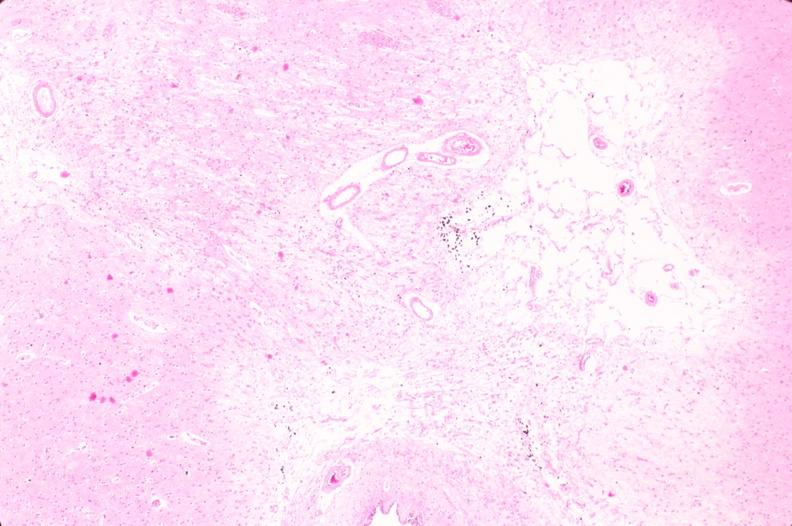why does this image show brain, infarct?
Answer the question using a single word or phrase. Due to ruptured saccular aneurysm and thrombosis of right middle cerebral artery 